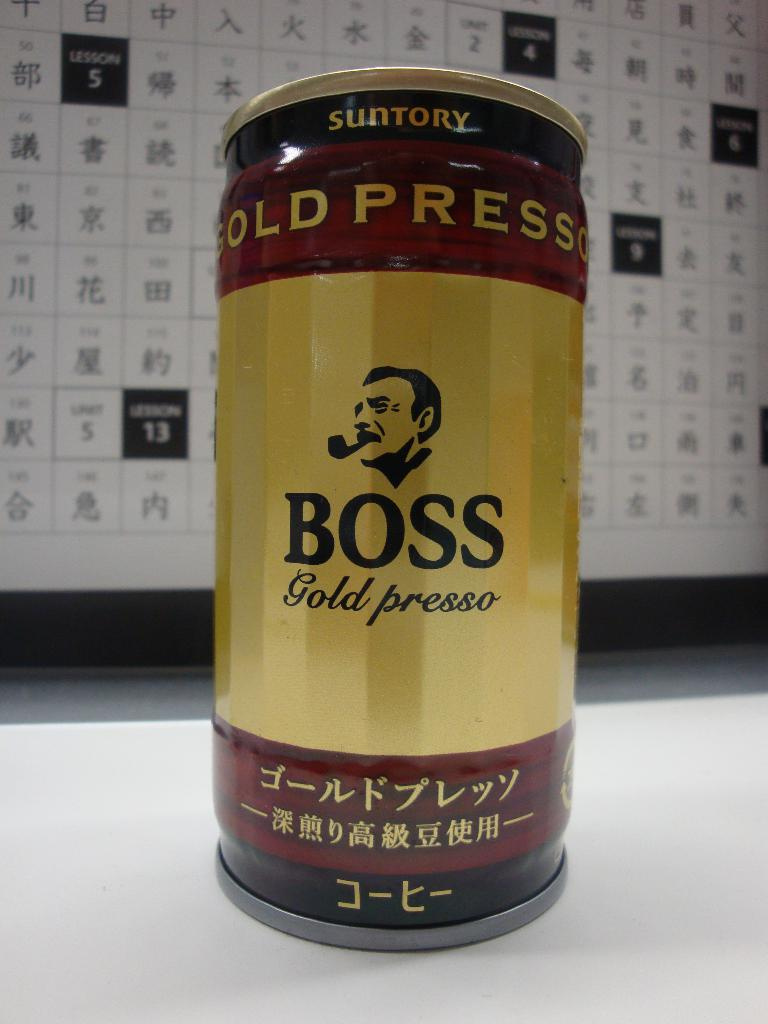What is the possible significance of the imagery used on the can's logo? The logo featuring a man smoking a pipe exudes a vintage, classic vibe, suggesting that the coffee may be targeting consumers who appreciate tradition and nostalgia, possibly hinting at a rich, time-honored blend. 